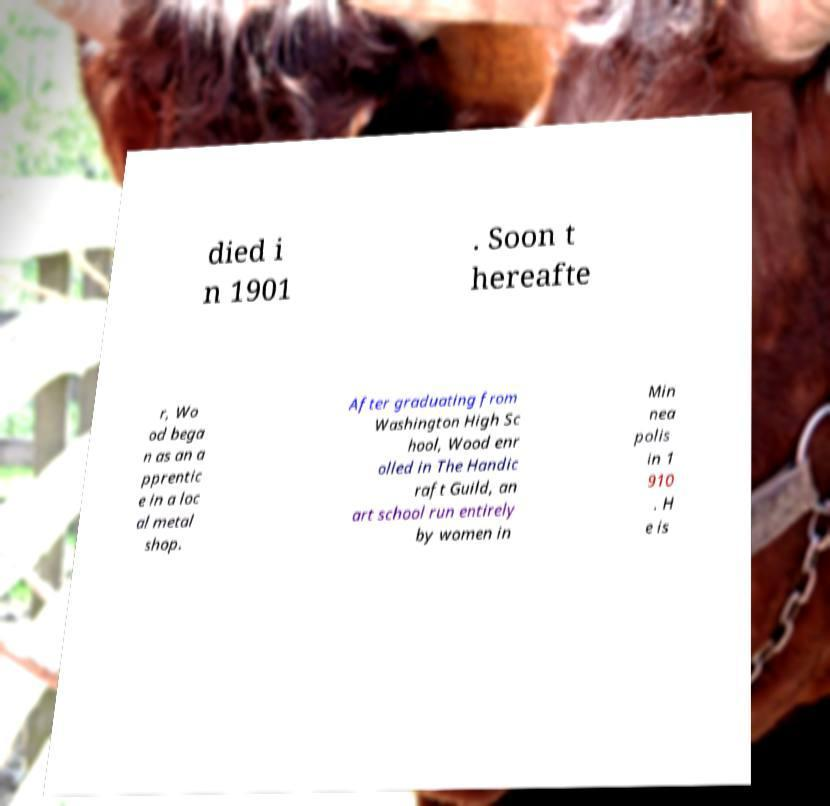I need the written content from this picture converted into text. Can you do that? died i n 1901 . Soon t hereafte r, Wo od bega n as an a pprentic e in a loc al metal shop. After graduating from Washington High Sc hool, Wood enr olled in The Handic raft Guild, an art school run entirely by women in Min nea polis in 1 910 . H e is 